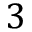<formula> <loc_0><loc_0><loc_500><loc_500>3</formula> 